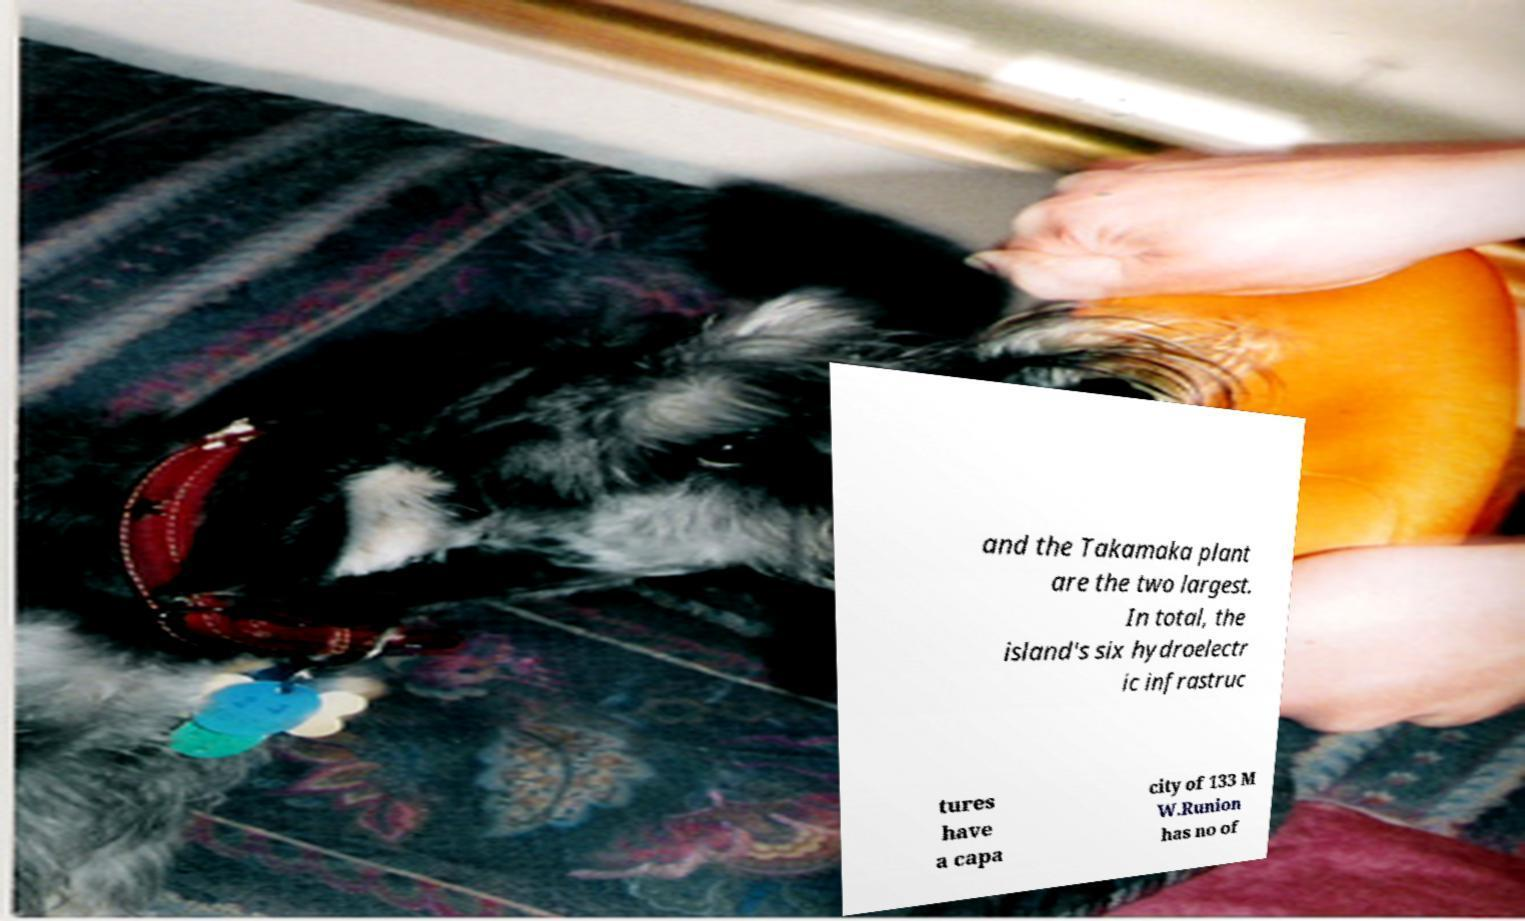Please identify and transcribe the text found in this image. and the Takamaka plant are the two largest. In total, the island's six hydroelectr ic infrastruc tures have a capa city of 133 M W.Runion has no of 